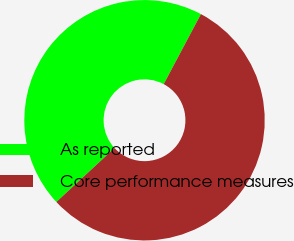Convert chart. <chart><loc_0><loc_0><loc_500><loc_500><pie_chart><fcel>As reported<fcel>Core performance measures<nl><fcel>44.67%<fcel>55.33%<nl></chart> 